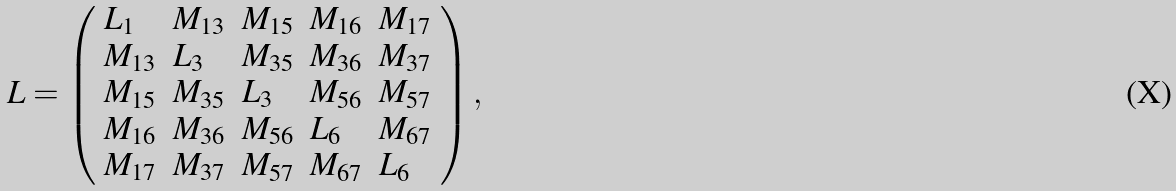Convert formula to latex. <formula><loc_0><loc_0><loc_500><loc_500>L = \left ( \begin{array} { l l l l l } L _ { 1 } & M _ { 1 3 } & M _ { 1 5 } & M _ { 1 6 } & M _ { 1 7 } \\ M _ { 1 3 } & L _ { 3 } & M _ { 3 5 } & M _ { 3 6 } & M _ { 3 7 } \\ M _ { 1 5 } & M _ { 3 5 } & L _ { 3 } & M _ { 5 6 } & M _ { 5 7 } \\ M _ { 1 6 } & M _ { 3 6 } & M _ { 5 6 } & L _ { 6 } & M _ { 6 7 } \\ M _ { 1 7 } & M _ { 3 7 } & M _ { 5 7 } & M _ { 6 7 } & L _ { 6 } \end{array} \right ) ,</formula> 